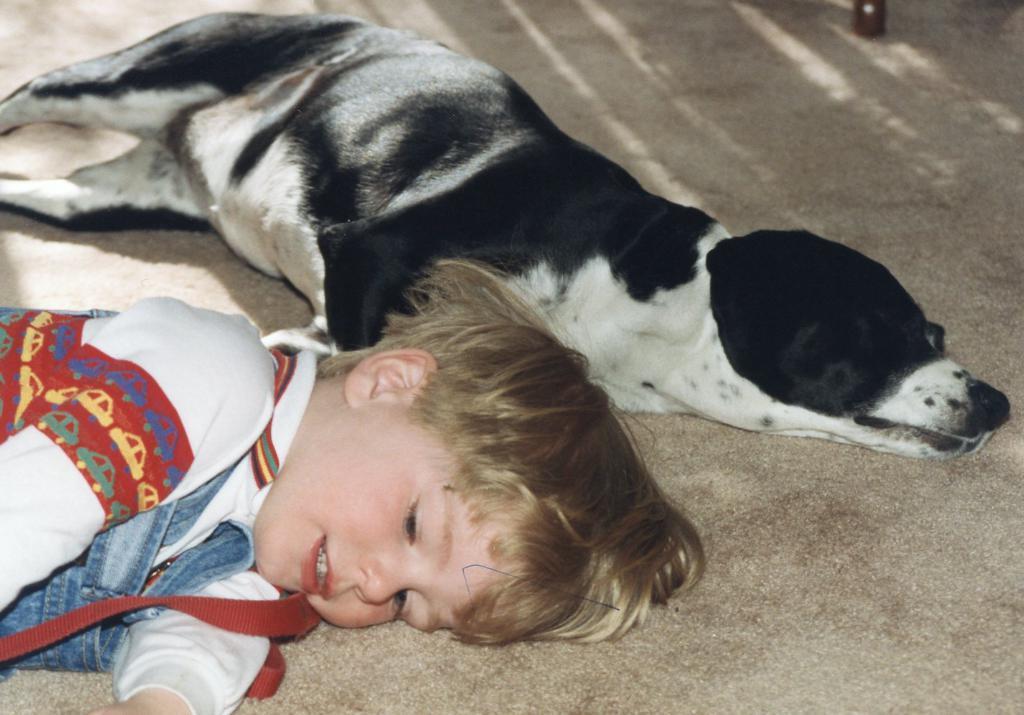In one or two sentences, can you explain what this image depicts? I can see a boy and a dog lying on the floor. This dog is black and white in color. 